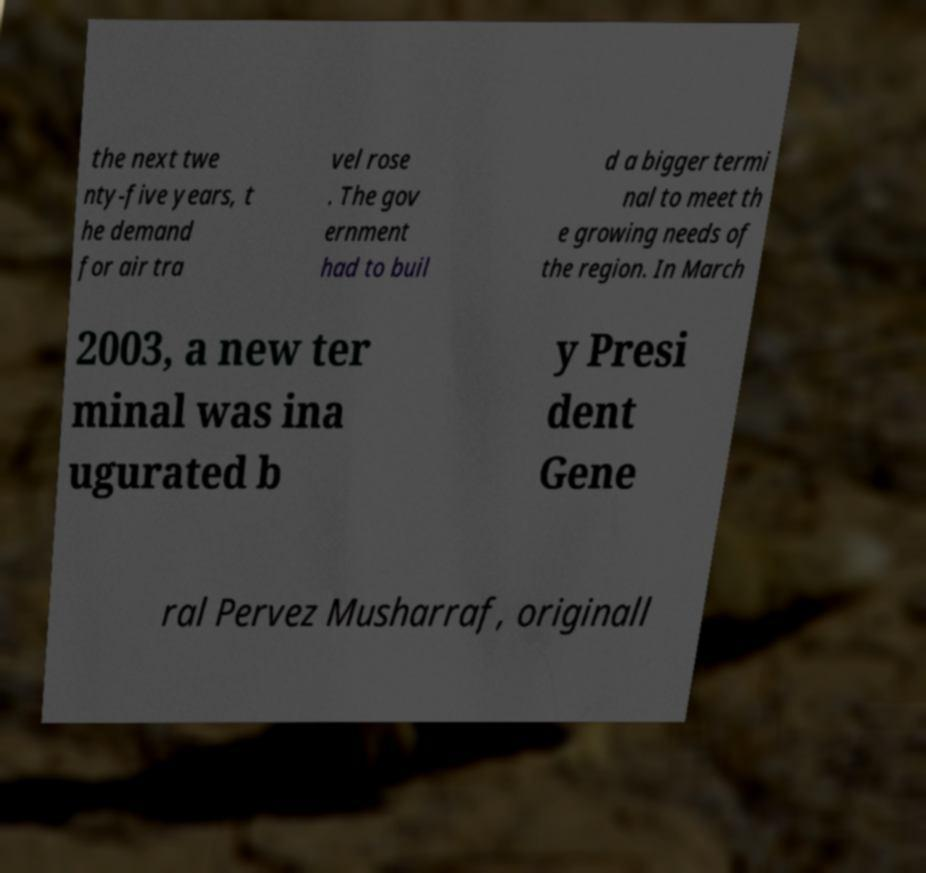Please read and relay the text visible in this image. What does it say? the next twe nty-five years, t he demand for air tra vel rose . The gov ernment had to buil d a bigger termi nal to meet th e growing needs of the region. In March 2003, a new ter minal was ina ugurated b y Presi dent Gene ral Pervez Musharraf, originall 